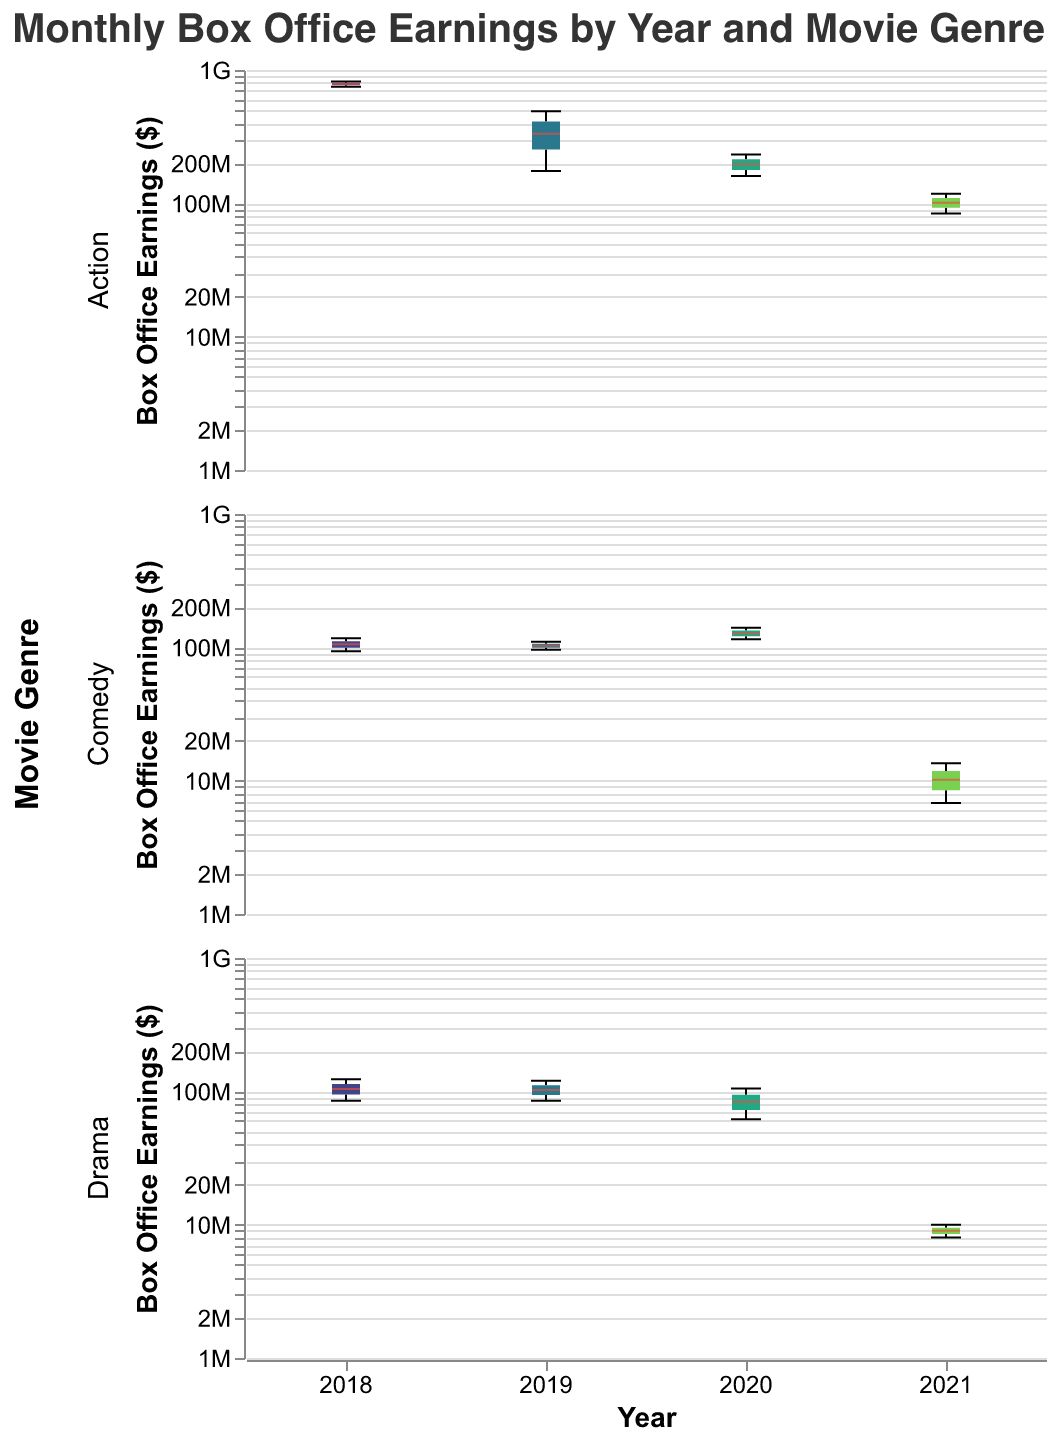What is the title of the figure? The title can be found at the top of the figure.
Answer: Monthly Box Office Earnings by Year and Movie Genre Which year had the highest box office earnings in the Action genre? Look at the Action genre subplot and identify the year with the highest box plot whisker.
Answer: 2018 What is the median box office earning for Comedy movies in March 2020? Locate the March subplot for the Comedy genre in 2020 and observe the median line within the box plot.
Answer: $127,500,000 Compare the median box office earnings for Drama movies in 2019 to those in 2021. Which year was higher? Check the median lines within the box plots for Drama movies in 2019 and 2021, and compare them.
Answer: 2019 How many unique years are represented in the Drama genre subplot? Count the number of distinct boxes or colors in the Drama subplot.
Answer: 4 What is the range of box office earnings for Action movies in February 2019? Identify the minimum and maximum whisker values in the box plot for Action movies in February 2019 and calculate the range.
Answer: $315,000,000 Which genre shows the greatest variability in box office earnings in January across all years? Look at the range of whiskers in January subplots for all genres and compare them.
Answer: Drama Describe the trend in box office earnings for Comedy movies from 2018 to 2021. Observe the median lines and whiskers in the Comedy subplots for each year from 2018 to 2021 and describe the pattern.
Answer: Decreasing For Action genre movies in February, which year has the smallest interquartile range (IQR)? Identify the February box plots in the Action genre and measure the box height (IQR) to find the smallest one.
Answer: 2021 